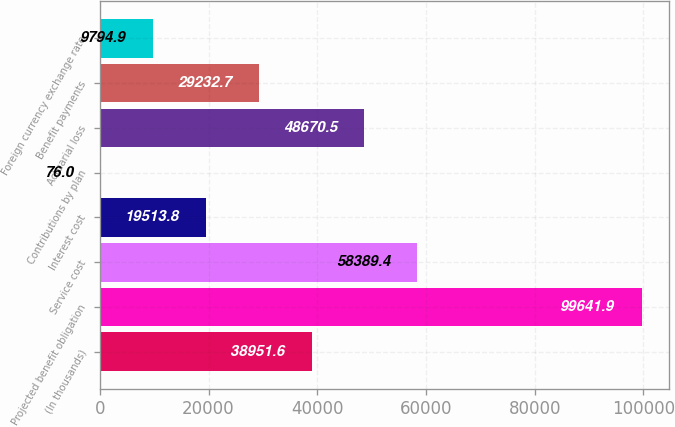Convert chart to OTSL. <chart><loc_0><loc_0><loc_500><loc_500><bar_chart><fcel>(In thousands)<fcel>Projected benefit obligation<fcel>Service cost<fcel>Interest cost<fcel>Contributions by plan<fcel>Actuarial loss<fcel>Benefit payments<fcel>Foreign currency exchange rate<nl><fcel>38951.6<fcel>99641.9<fcel>58389.4<fcel>19513.8<fcel>76<fcel>48670.5<fcel>29232.7<fcel>9794.9<nl></chart> 